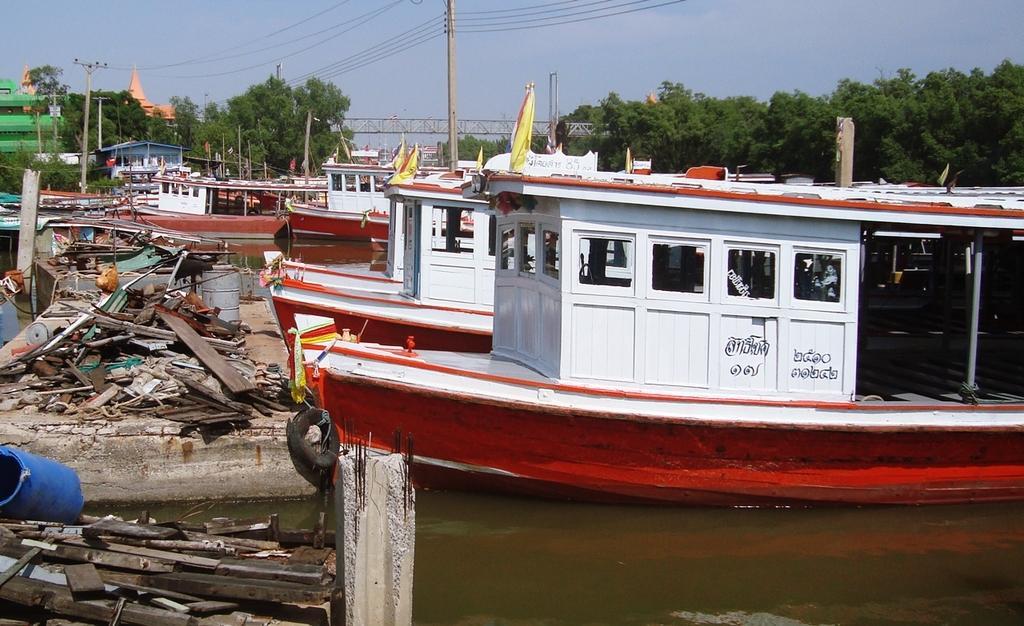In one or two sentences, can you explain what this image depicts? Here in this picture we can see boats present at the dock of the river, as we can see water present over there and we can see some scrap present in front of it and in the far we an see buildings present and we can see plants and trees all over there and we can see electric poles present, with wires connected to it over there and in the middle we can see a bridge also present over there. 